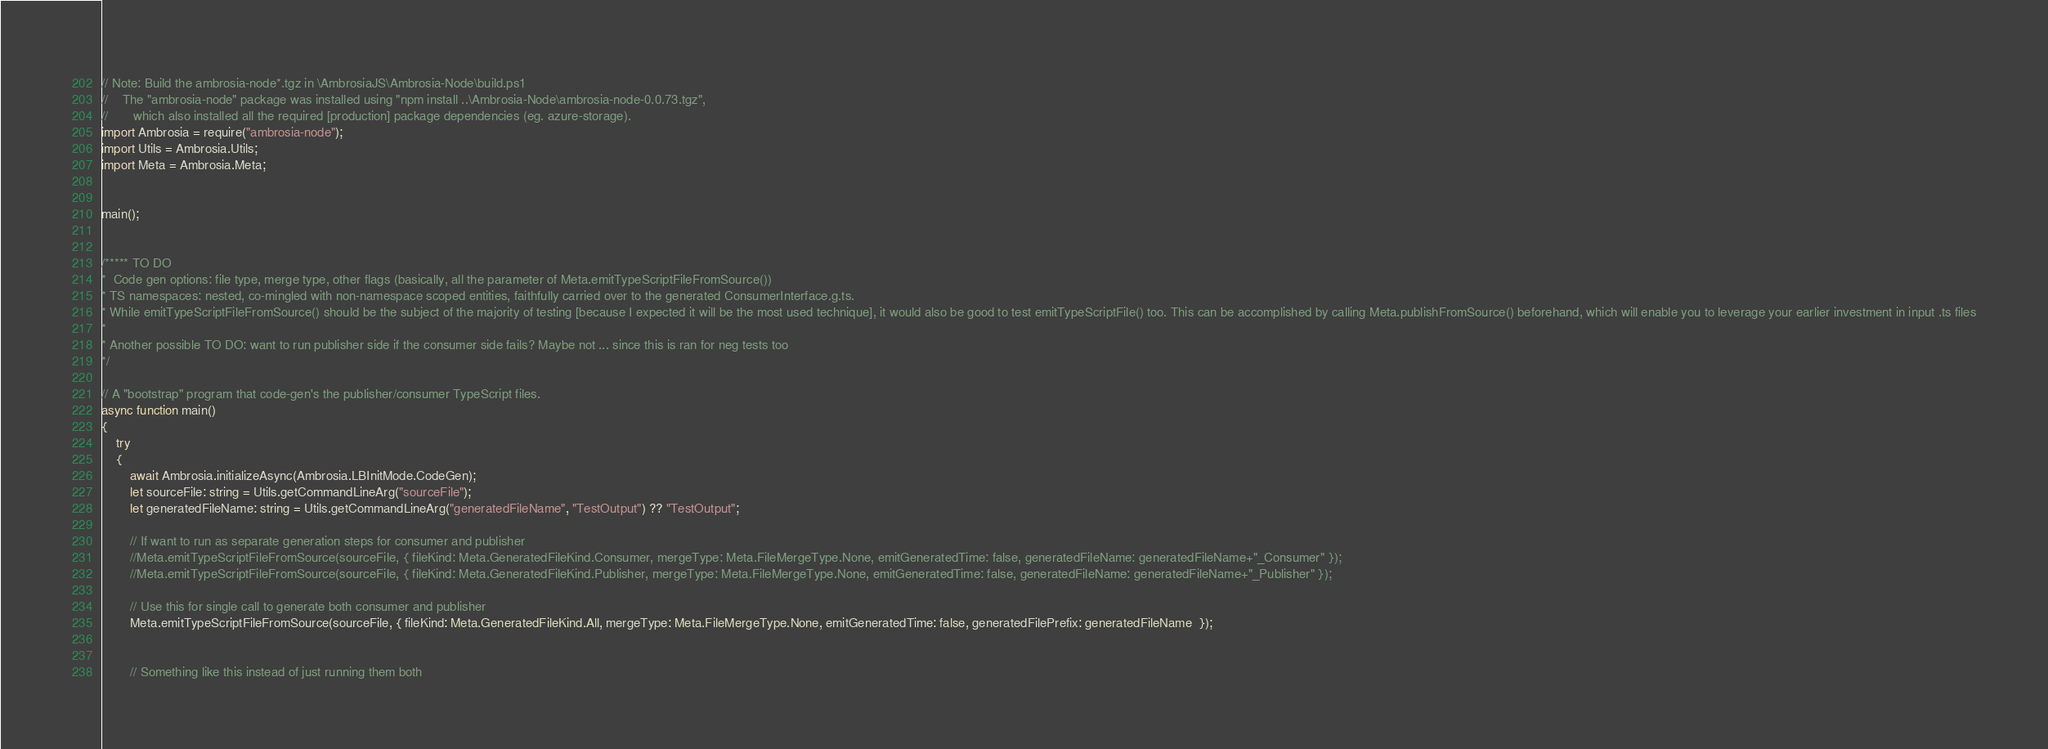Convert code to text. <code><loc_0><loc_0><loc_500><loc_500><_TypeScript_>// Note: Build the ambrosia-node*.tgz in \AmbrosiaJS\Ambrosia-Node\build.ps1
//    The "ambrosia-node" package was installed using "npm install ..\Ambrosia-Node\ambrosia-node-0.0.73.tgz", 
//       which also installed all the required [production] package dependencies (eg. azure-storage).
import Ambrosia = require("ambrosia-node"); 
import Utils = Ambrosia.Utils;
import Meta = Ambrosia.Meta;


main();

 
/***** TO DO 
*  Code gen options: file type, merge type, other flags (basically, all the parameter of Meta.emitTypeScriptFileFromSource())
* TS namespaces: nested, co-mingled with non-namespace scoped entities, faithfully carried over to the generated ConsumerInterface.g.ts.
* While emitTypeScriptFileFromSource() should be the subject of the majority of testing [because I expected it will be the most used technique], it would also be good to test emitTypeScriptFile() too. This can be accomplished by calling Meta.publishFromSource() beforehand, which will enable you to leverage your earlier investment in input .ts files
*
* Another possible TO DO: want to run publisher side if the consumer side fails? Maybe not ... since this is ran for neg tests too 
*/

// A "bootstrap" program that code-gen's the publisher/consumer TypeScript files.
async function main()
{
    try
    {
        await Ambrosia.initializeAsync(Ambrosia.LBInitMode.CodeGen);
        let sourceFile: string = Utils.getCommandLineArg("sourceFile");
        let generatedFileName: string = Utils.getCommandLineArg("generatedFileName", "TestOutput") ?? "TestOutput";

        // If want to run as separate generation steps for consumer and publisher
        //Meta.emitTypeScriptFileFromSource(sourceFile, { fileKind: Meta.GeneratedFileKind.Consumer, mergeType: Meta.FileMergeType.None, emitGeneratedTime: false, generatedFileName: generatedFileName+"_Consumer" });
        //Meta.emitTypeScriptFileFromSource(sourceFile, { fileKind: Meta.GeneratedFileKind.Publisher, mergeType: Meta.FileMergeType.None, emitGeneratedTime: false, generatedFileName: generatedFileName+"_Publisher" });

        // Use this for single call to generate both consumer and publisher
        Meta.emitTypeScriptFileFromSource(sourceFile, { fileKind: Meta.GeneratedFileKind.All, mergeType: Meta.FileMergeType.None, emitGeneratedTime: false, generatedFilePrefix: generatedFileName  });


        // Something like this instead of just running them both</code> 